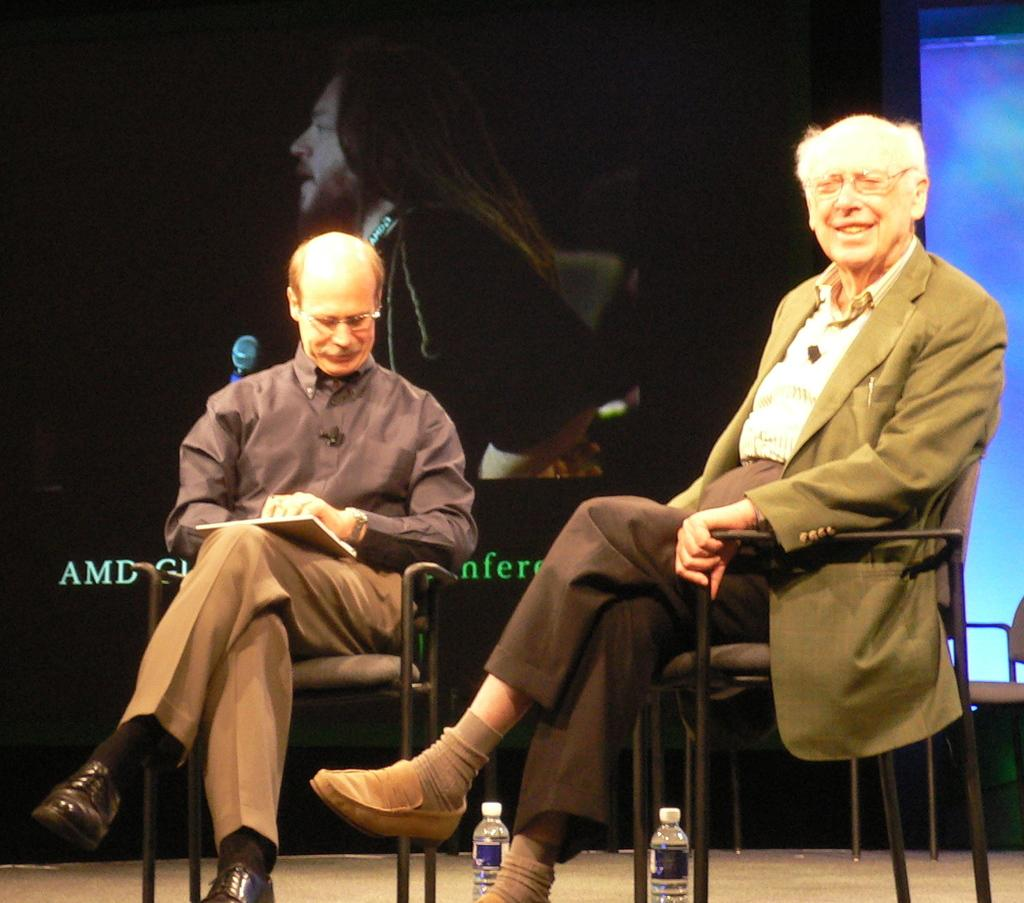How many people are sitting in the image? There are two people sitting on chairs in the image. What is on the floor near the people? There are bottles on the floor in the image. Can you describe the background of the image? There is a picture of a person in the background of the image. What type of building can be seen at the edge of the image? There is no building present in the image. 